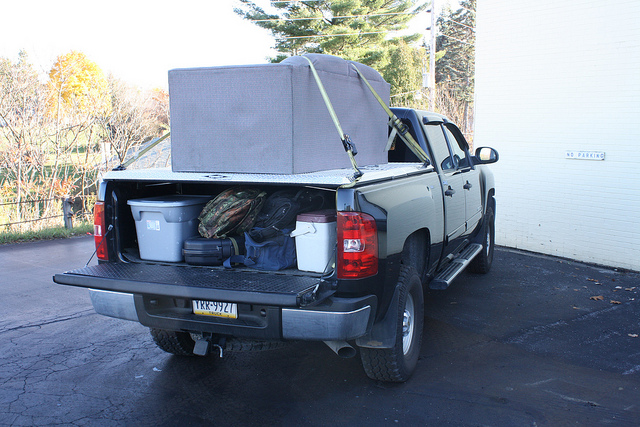<image>What pattern is shown on the book bag? I am not sure. It can be a camouflage or camo pattern on the book bag. However, there is also a possibility of no pattern. What pattern is shown on the book bag? It is unknown what pattern is shown on the book bag. It can be either camouflage or camo. 